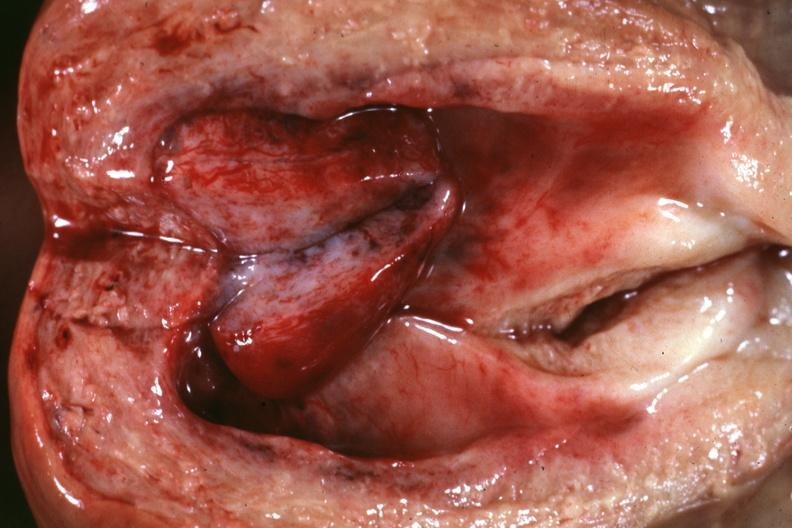what is present?
Answer the question using a single word or phrase. Female reproductive 